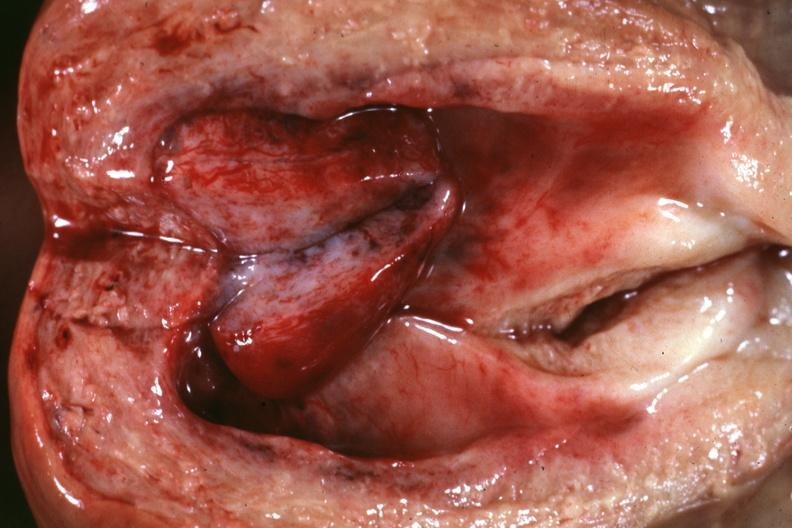what is present?
Answer the question using a single word or phrase. Female reproductive 